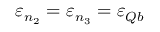<formula> <loc_0><loc_0><loc_500><loc_500>\varepsilon _ { n _ { 2 } } = \varepsilon _ { n _ { 3 } } = \varepsilon _ { Q b }</formula> 